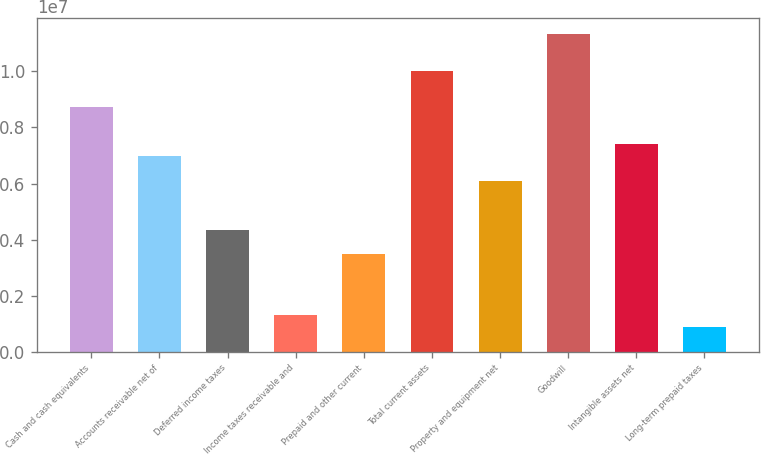Convert chart to OTSL. <chart><loc_0><loc_0><loc_500><loc_500><bar_chart><fcel>Cash and cash equivalents<fcel>Accounts receivable net of<fcel>Deferred income taxes<fcel>Income taxes receivable and<fcel>Prepaid and other current<fcel>Total current assets<fcel>Property and equipment net<fcel>Goodwill<fcel>Intangible assets net<fcel>Long-term prepaid taxes<nl><fcel>8.71633e+06<fcel>6.97337e+06<fcel>4.35894e+06<fcel>1.30876e+06<fcel>3.48746e+06<fcel>1.00235e+07<fcel>6.10189e+06<fcel>1.13308e+07<fcel>7.40911e+06<fcel>873021<nl></chart> 